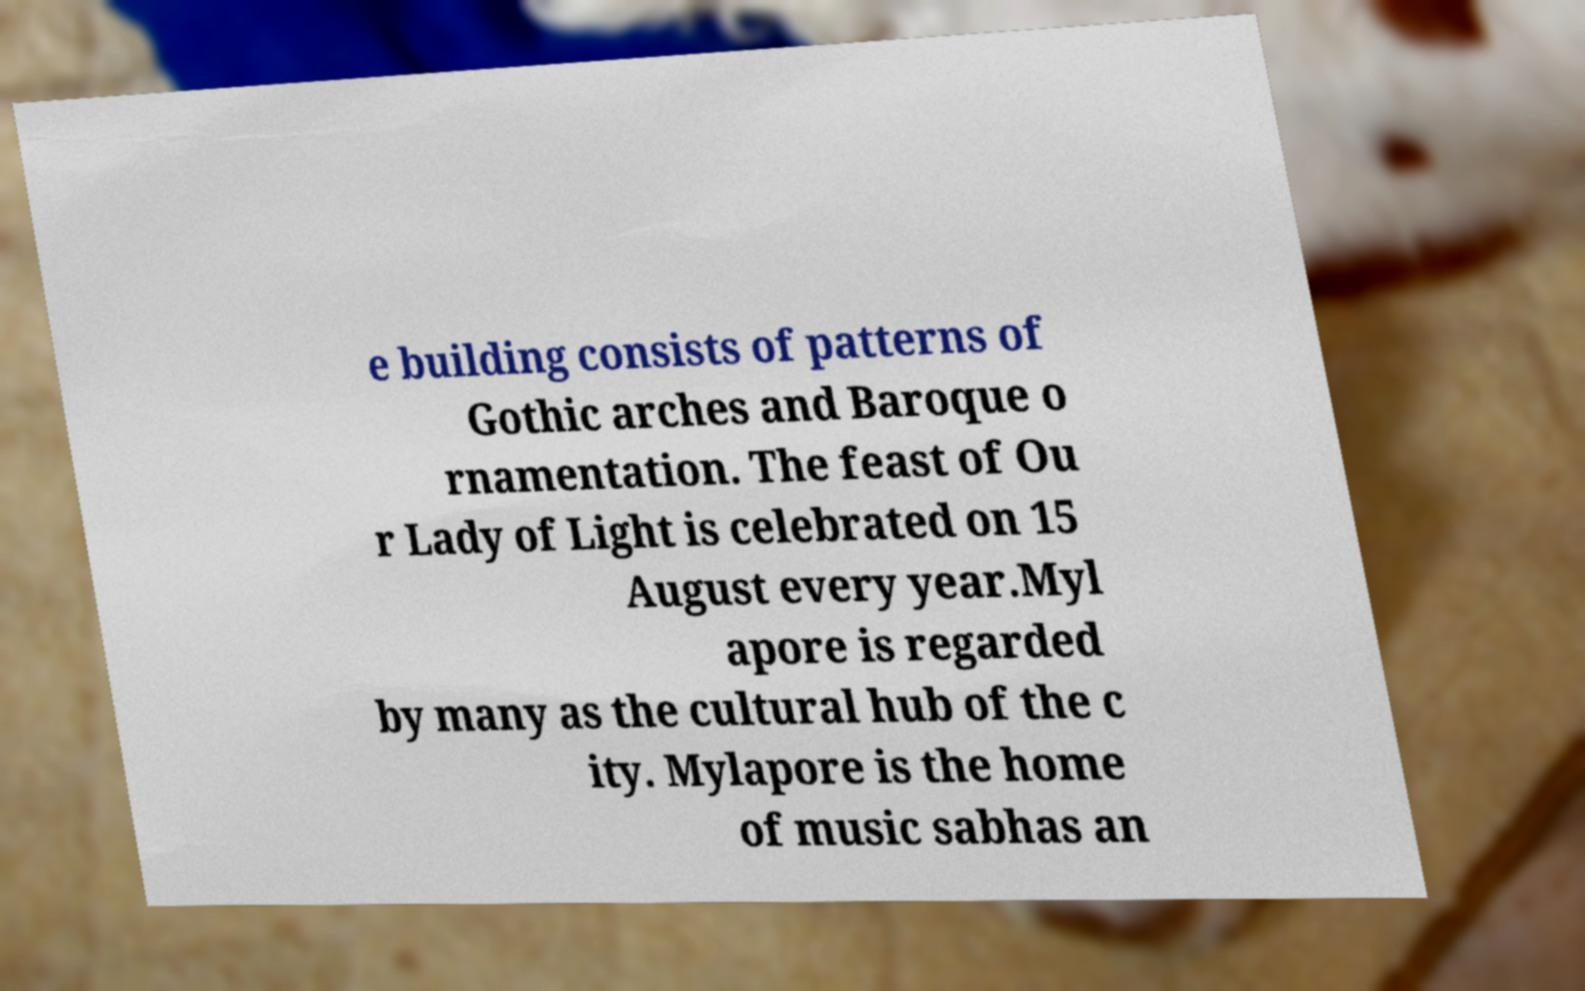There's text embedded in this image that I need extracted. Can you transcribe it verbatim? e building consists of patterns of Gothic arches and Baroque o rnamentation. The feast of Ou r Lady of Light is celebrated on 15 August every year.Myl apore is regarded by many as the cultural hub of the c ity. Mylapore is the home of music sabhas an 